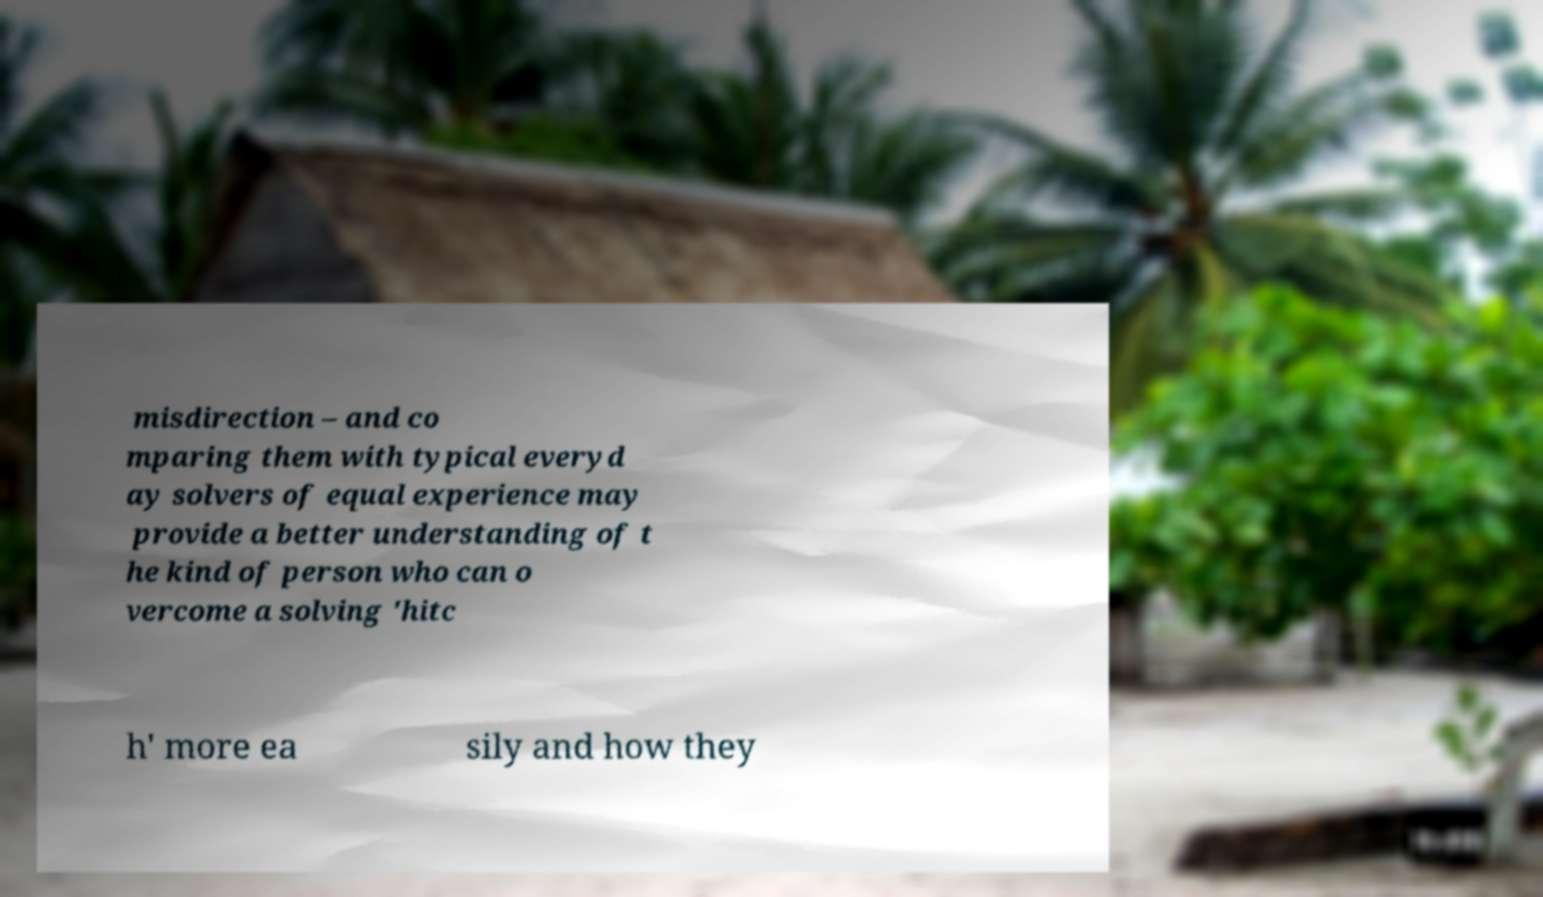Can you accurately transcribe the text from the provided image for me? misdirection – and co mparing them with typical everyd ay solvers of equal experience may provide a better understanding of t he kind of person who can o vercome a solving 'hitc h' more ea sily and how they 